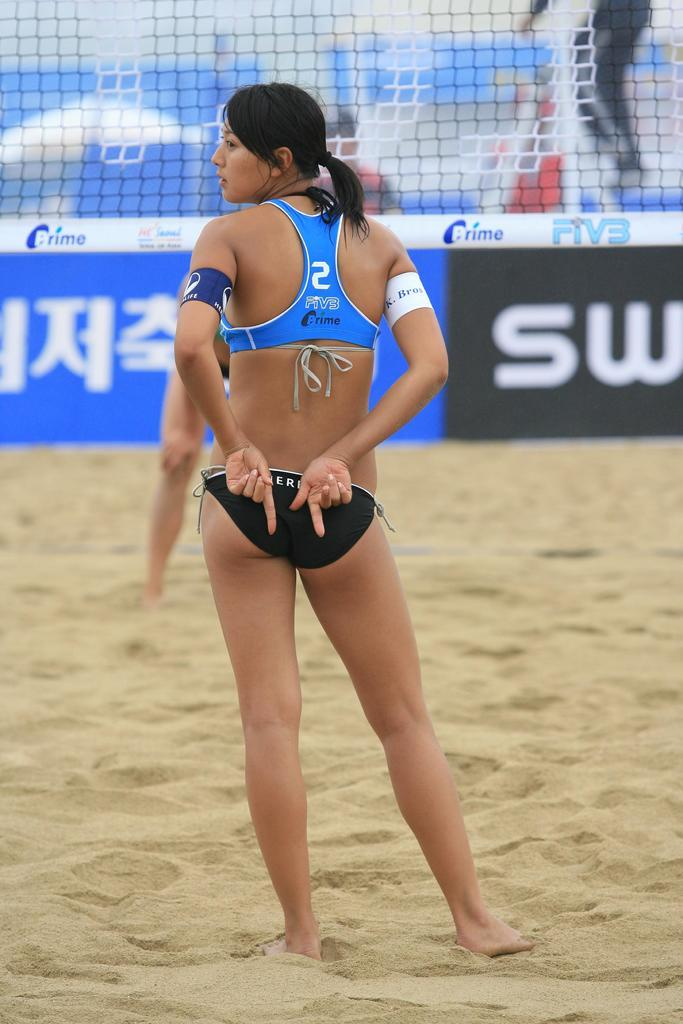<image>
Present a compact description of the photo's key features. A player wearing number 2 during a beach volleyball game. 